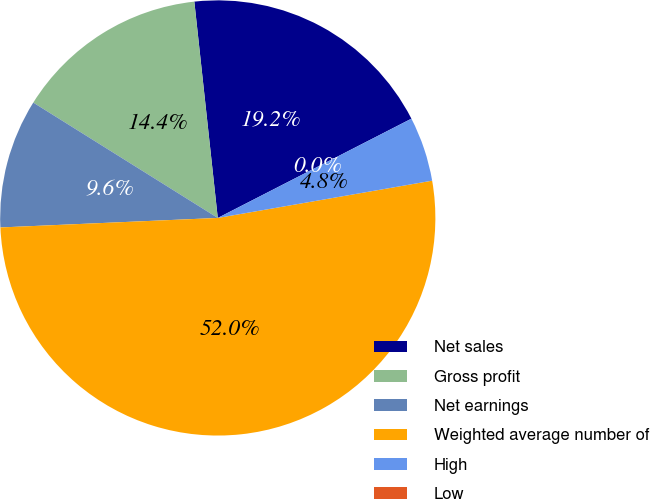<chart> <loc_0><loc_0><loc_500><loc_500><pie_chart><fcel>Net sales<fcel>Gross profit<fcel>Net earnings<fcel>Weighted average number of<fcel>High<fcel>Low<nl><fcel>19.18%<fcel>14.39%<fcel>9.59%<fcel>52.05%<fcel>4.8%<fcel>0.0%<nl></chart> 